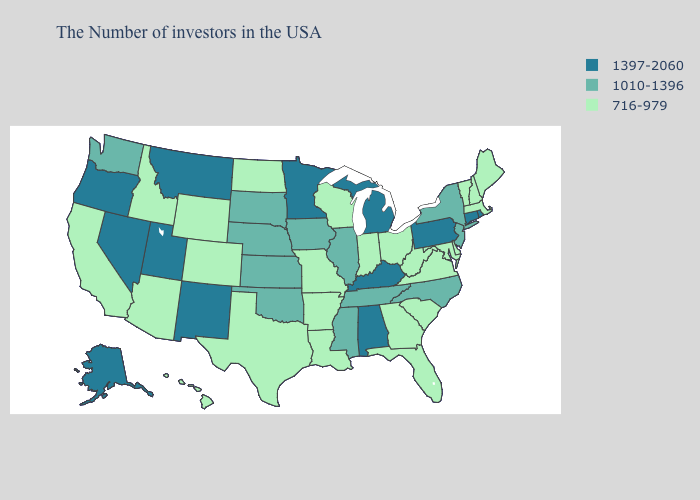What is the value of Delaware?
Short answer required. 716-979. Does West Virginia have the highest value in the South?
Answer briefly. No. Name the states that have a value in the range 1397-2060?
Quick response, please. Rhode Island, Connecticut, Pennsylvania, Michigan, Kentucky, Alabama, Minnesota, New Mexico, Utah, Montana, Nevada, Oregon, Alaska. What is the value of Vermont?
Keep it brief. 716-979. Name the states that have a value in the range 1010-1396?
Keep it brief. New York, New Jersey, North Carolina, Tennessee, Illinois, Mississippi, Iowa, Kansas, Nebraska, Oklahoma, South Dakota, Washington. Does Hawaii have a higher value than Florida?
Write a very short answer. No. What is the value of Alabama?
Answer briefly. 1397-2060. Does Illinois have a higher value than North Dakota?
Write a very short answer. Yes. Name the states that have a value in the range 1010-1396?
Be succinct. New York, New Jersey, North Carolina, Tennessee, Illinois, Mississippi, Iowa, Kansas, Nebraska, Oklahoma, South Dakota, Washington. Is the legend a continuous bar?
Answer briefly. No. What is the value of Iowa?
Concise answer only. 1010-1396. What is the lowest value in the South?
Be succinct. 716-979. What is the value of New Hampshire?
Answer briefly. 716-979. Name the states that have a value in the range 716-979?
Write a very short answer. Maine, Massachusetts, New Hampshire, Vermont, Delaware, Maryland, Virginia, South Carolina, West Virginia, Ohio, Florida, Georgia, Indiana, Wisconsin, Louisiana, Missouri, Arkansas, Texas, North Dakota, Wyoming, Colorado, Arizona, Idaho, California, Hawaii. Name the states that have a value in the range 1397-2060?
Short answer required. Rhode Island, Connecticut, Pennsylvania, Michigan, Kentucky, Alabama, Minnesota, New Mexico, Utah, Montana, Nevada, Oregon, Alaska. 